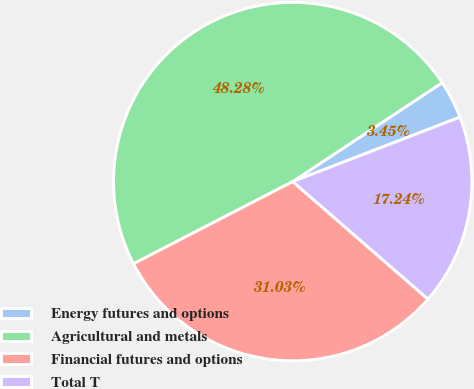Convert chart to OTSL. <chart><loc_0><loc_0><loc_500><loc_500><pie_chart><fcel>Energy futures and options<fcel>Agricultural and metals<fcel>Financial futures and options<fcel>Total T<nl><fcel>3.45%<fcel>48.28%<fcel>31.03%<fcel>17.24%<nl></chart> 